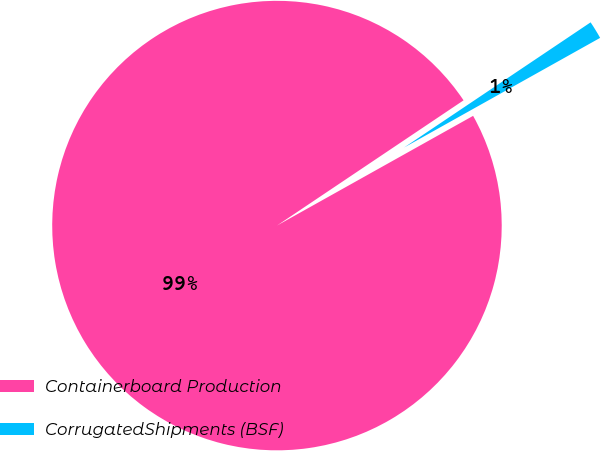<chart> <loc_0><loc_0><loc_500><loc_500><pie_chart><fcel>Containerboard Production<fcel>CorrugatedShipments (BSF)<nl><fcel>98.71%<fcel>1.29%<nl></chart> 